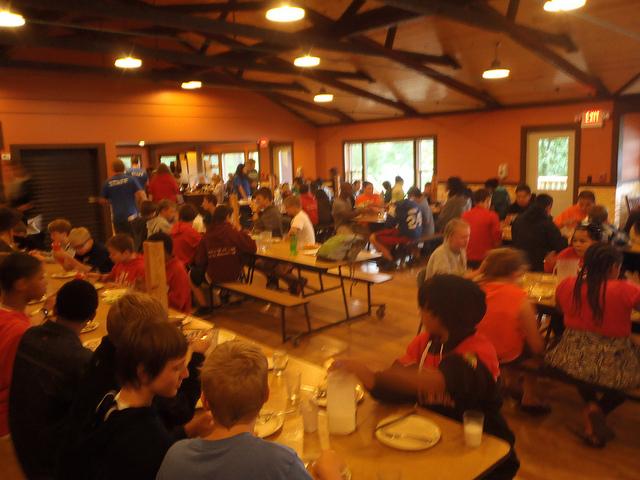Is this a busy restaurant?
Keep it brief. Yes. Are these people eating a meal?
Be succinct. Yes. Are the kids at camp?
Short answer required. Yes. 